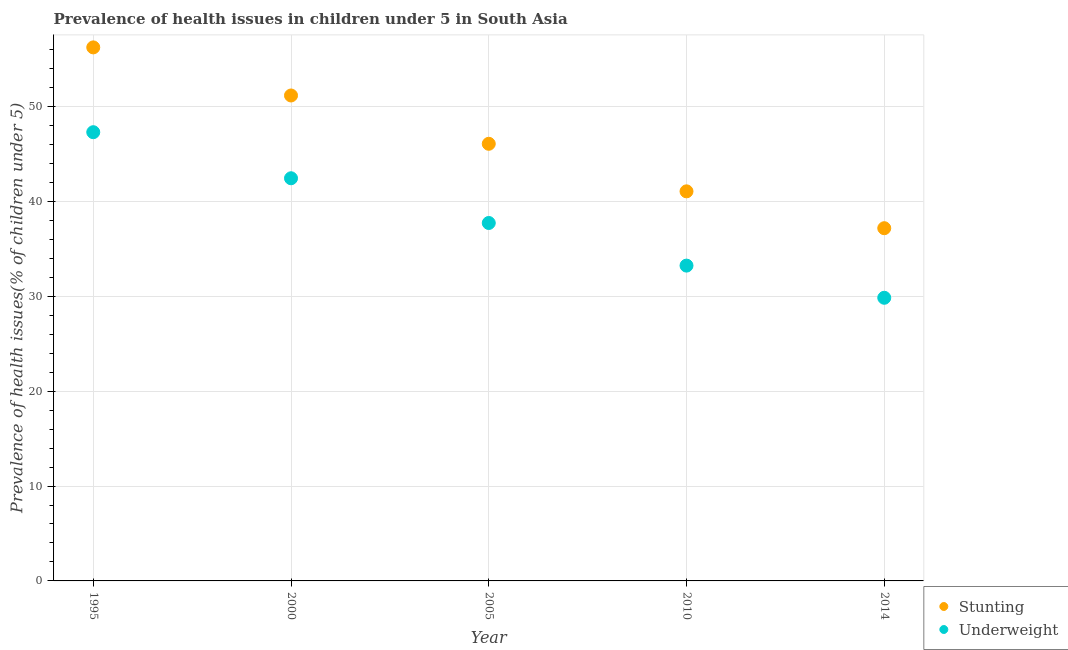What is the percentage of stunted children in 2000?
Give a very brief answer. 51.16. Across all years, what is the maximum percentage of underweight children?
Make the answer very short. 47.29. Across all years, what is the minimum percentage of underweight children?
Offer a terse response. 29.84. In which year was the percentage of stunted children maximum?
Provide a succinct answer. 1995. In which year was the percentage of stunted children minimum?
Offer a very short reply. 2014. What is the total percentage of underweight children in the graph?
Provide a short and direct response. 190.53. What is the difference between the percentage of underweight children in 2000 and that in 2005?
Offer a very short reply. 4.71. What is the difference between the percentage of stunted children in 2000 and the percentage of underweight children in 2005?
Ensure brevity in your answer.  13.44. What is the average percentage of underweight children per year?
Ensure brevity in your answer.  38.11. In the year 2005, what is the difference between the percentage of stunted children and percentage of underweight children?
Keep it short and to the point. 8.35. In how many years, is the percentage of underweight children greater than 38 %?
Make the answer very short. 2. What is the ratio of the percentage of stunted children in 2000 to that in 2010?
Ensure brevity in your answer.  1.25. Is the difference between the percentage of stunted children in 2010 and 2014 greater than the difference between the percentage of underweight children in 2010 and 2014?
Your answer should be very brief. Yes. What is the difference between the highest and the second highest percentage of underweight children?
Make the answer very short. 4.86. What is the difference between the highest and the lowest percentage of underweight children?
Give a very brief answer. 17.45. Is the percentage of stunted children strictly greater than the percentage of underweight children over the years?
Your answer should be very brief. Yes. How many dotlines are there?
Your response must be concise. 2. Are the values on the major ticks of Y-axis written in scientific E-notation?
Ensure brevity in your answer.  No. Does the graph contain any zero values?
Ensure brevity in your answer.  No. How many legend labels are there?
Ensure brevity in your answer.  2. What is the title of the graph?
Ensure brevity in your answer.  Prevalence of health issues in children under 5 in South Asia. Does "Age 65(male)" appear as one of the legend labels in the graph?
Your response must be concise. No. What is the label or title of the Y-axis?
Offer a terse response. Prevalence of health issues(% of children under 5). What is the Prevalence of health issues(% of children under 5) of Stunting in 1995?
Your answer should be compact. 56.23. What is the Prevalence of health issues(% of children under 5) in Underweight in 1995?
Provide a short and direct response. 47.29. What is the Prevalence of health issues(% of children under 5) in Stunting in 2000?
Give a very brief answer. 51.16. What is the Prevalence of health issues(% of children under 5) in Underweight in 2000?
Provide a short and direct response. 42.44. What is the Prevalence of health issues(% of children under 5) in Stunting in 2005?
Offer a very short reply. 46.07. What is the Prevalence of health issues(% of children under 5) in Underweight in 2005?
Provide a short and direct response. 37.72. What is the Prevalence of health issues(% of children under 5) in Stunting in 2010?
Ensure brevity in your answer.  41.06. What is the Prevalence of health issues(% of children under 5) in Underweight in 2010?
Your answer should be very brief. 33.23. What is the Prevalence of health issues(% of children under 5) of Stunting in 2014?
Provide a short and direct response. 37.17. What is the Prevalence of health issues(% of children under 5) in Underweight in 2014?
Your response must be concise. 29.84. Across all years, what is the maximum Prevalence of health issues(% of children under 5) of Stunting?
Offer a very short reply. 56.23. Across all years, what is the maximum Prevalence of health issues(% of children under 5) of Underweight?
Offer a very short reply. 47.29. Across all years, what is the minimum Prevalence of health issues(% of children under 5) of Stunting?
Make the answer very short. 37.17. Across all years, what is the minimum Prevalence of health issues(% of children under 5) of Underweight?
Your answer should be very brief. 29.84. What is the total Prevalence of health issues(% of children under 5) of Stunting in the graph?
Your response must be concise. 231.7. What is the total Prevalence of health issues(% of children under 5) in Underweight in the graph?
Ensure brevity in your answer.  190.53. What is the difference between the Prevalence of health issues(% of children under 5) in Stunting in 1995 and that in 2000?
Provide a succinct answer. 5.07. What is the difference between the Prevalence of health issues(% of children under 5) of Underweight in 1995 and that in 2000?
Your response must be concise. 4.86. What is the difference between the Prevalence of health issues(% of children under 5) in Stunting in 1995 and that in 2005?
Give a very brief answer. 10.16. What is the difference between the Prevalence of health issues(% of children under 5) of Underweight in 1995 and that in 2005?
Provide a succinct answer. 9.57. What is the difference between the Prevalence of health issues(% of children under 5) of Stunting in 1995 and that in 2010?
Give a very brief answer. 15.17. What is the difference between the Prevalence of health issues(% of children under 5) of Underweight in 1995 and that in 2010?
Your answer should be compact. 14.06. What is the difference between the Prevalence of health issues(% of children under 5) in Stunting in 1995 and that in 2014?
Keep it short and to the point. 19.06. What is the difference between the Prevalence of health issues(% of children under 5) of Underweight in 1995 and that in 2014?
Offer a very short reply. 17.45. What is the difference between the Prevalence of health issues(% of children under 5) in Stunting in 2000 and that in 2005?
Offer a very short reply. 5.09. What is the difference between the Prevalence of health issues(% of children under 5) of Underweight in 2000 and that in 2005?
Offer a very short reply. 4.71. What is the difference between the Prevalence of health issues(% of children under 5) of Stunting in 2000 and that in 2010?
Offer a terse response. 10.1. What is the difference between the Prevalence of health issues(% of children under 5) of Underweight in 2000 and that in 2010?
Your answer should be very brief. 9.21. What is the difference between the Prevalence of health issues(% of children under 5) in Stunting in 2000 and that in 2014?
Your answer should be very brief. 13.99. What is the difference between the Prevalence of health issues(% of children under 5) of Underweight in 2000 and that in 2014?
Your response must be concise. 12.6. What is the difference between the Prevalence of health issues(% of children under 5) in Stunting in 2005 and that in 2010?
Give a very brief answer. 5.01. What is the difference between the Prevalence of health issues(% of children under 5) in Underweight in 2005 and that in 2010?
Provide a short and direct response. 4.49. What is the difference between the Prevalence of health issues(% of children under 5) of Stunting in 2005 and that in 2014?
Make the answer very short. 8.9. What is the difference between the Prevalence of health issues(% of children under 5) in Underweight in 2005 and that in 2014?
Ensure brevity in your answer.  7.88. What is the difference between the Prevalence of health issues(% of children under 5) of Stunting in 2010 and that in 2014?
Keep it short and to the point. 3.88. What is the difference between the Prevalence of health issues(% of children under 5) in Underweight in 2010 and that in 2014?
Your answer should be compact. 3.39. What is the difference between the Prevalence of health issues(% of children under 5) in Stunting in 1995 and the Prevalence of health issues(% of children under 5) in Underweight in 2000?
Provide a short and direct response. 13.79. What is the difference between the Prevalence of health issues(% of children under 5) of Stunting in 1995 and the Prevalence of health issues(% of children under 5) of Underweight in 2005?
Provide a short and direct response. 18.51. What is the difference between the Prevalence of health issues(% of children under 5) in Stunting in 1995 and the Prevalence of health issues(% of children under 5) in Underweight in 2010?
Offer a very short reply. 23. What is the difference between the Prevalence of health issues(% of children under 5) of Stunting in 1995 and the Prevalence of health issues(% of children under 5) of Underweight in 2014?
Provide a succinct answer. 26.39. What is the difference between the Prevalence of health issues(% of children under 5) in Stunting in 2000 and the Prevalence of health issues(% of children under 5) in Underweight in 2005?
Your answer should be compact. 13.44. What is the difference between the Prevalence of health issues(% of children under 5) of Stunting in 2000 and the Prevalence of health issues(% of children under 5) of Underweight in 2010?
Offer a terse response. 17.93. What is the difference between the Prevalence of health issues(% of children under 5) in Stunting in 2000 and the Prevalence of health issues(% of children under 5) in Underweight in 2014?
Your answer should be very brief. 21.32. What is the difference between the Prevalence of health issues(% of children under 5) of Stunting in 2005 and the Prevalence of health issues(% of children under 5) of Underweight in 2010?
Your answer should be compact. 12.84. What is the difference between the Prevalence of health issues(% of children under 5) of Stunting in 2005 and the Prevalence of health issues(% of children under 5) of Underweight in 2014?
Make the answer very short. 16.23. What is the difference between the Prevalence of health issues(% of children under 5) of Stunting in 2010 and the Prevalence of health issues(% of children under 5) of Underweight in 2014?
Your answer should be compact. 11.22. What is the average Prevalence of health issues(% of children under 5) of Stunting per year?
Give a very brief answer. 46.34. What is the average Prevalence of health issues(% of children under 5) of Underweight per year?
Make the answer very short. 38.11. In the year 1995, what is the difference between the Prevalence of health issues(% of children under 5) in Stunting and Prevalence of health issues(% of children under 5) in Underweight?
Ensure brevity in your answer.  8.94. In the year 2000, what is the difference between the Prevalence of health issues(% of children under 5) of Stunting and Prevalence of health issues(% of children under 5) of Underweight?
Offer a terse response. 8.72. In the year 2005, what is the difference between the Prevalence of health issues(% of children under 5) in Stunting and Prevalence of health issues(% of children under 5) in Underweight?
Offer a terse response. 8.35. In the year 2010, what is the difference between the Prevalence of health issues(% of children under 5) in Stunting and Prevalence of health issues(% of children under 5) in Underweight?
Your answer should be very brief. 7.83. In the year 2014, what is the difference between the Prevalence of health issues(% of children under 5) of Stunting and Prevalence of health issues(% of children under 5) of Underweight?
Provide a short and direct response. 7.33. What is the ratio of the Prevalence of health issues(% of children under 5) of Stunting in 1995 to that in 2000?
Your answer should be compact. 1.1. What is the ratio of the Prevalence of health issues(% of children under 5) in Underweight in 1995 to that in 2000?
Provide a short and direct response. 1.11. What is the ratio of the Prevalence of health issues(% of children under 5) of Stunting in 1995 to that in 2005?
Keep it short and to the point. 1.22. What is the ratio of the Prevalence of health issues(% of children under 5) in Underweight in 1995 to that in 2005?
Make the answer very short. 1.25. What is the ratio of the Prevalence of health issues(% of children under 5) in Stunting in 1995 to that in 2010?
Your response must be concise. 1.37. What is the ratio of the Prevalence of health issues(% of children under 5) in Underweight in 1995 to that in 2010?
Give a very brief answer. 1.42. What is the ratio of the Prevalence of health issues(% of children under 5) in Stunting in 1995 to that in 2014?
Ensure brevity in your answer.  1.51. What is the ratio of the Prevalence of health issues(% of children under 5) of Underweight in 1995 to that in 2014?
Ensure brevity in your answer.  1.58. What is the ratio of the Prevalence of health issues(% of children under 5) of Stunting in 2000 to that in 2005?
Give a very brief answer. 1.11. What is the ratio of the Prevalence of health issues(% of children under 5) of Underweight in 2000 to that in 2005?
Give a very brief answer. 1.12. What is the ratio of the Prevalence of health issues(% of children under 5) of Stunting in 2000 to that in 2010?
Keep it short and to the point. 1.25. What is the ratio of the Prevalence of health issues(% of children under 5) in Underweight in 2000 to that in 2010?
Your response must be concise. 1.28. What is the ratio of the Prevalence of health issues(% of children under 5) in Stunting in 2000 to that in 2014?
Your response must be concise. 1.38. What is the ratio of the Prevalence of health issues(% of children under 5) of Underweight in 2000 to that in 2014?
Your answer should be compact. 1.42. What is the ratio of the Prevalence of health issues(% of children under 5) of Stunting in 2005 to that in 2010?
Your response must be concise. 1.12. What is the ratio of the Prevalence of health issues(% of children under 5) of Underweight in 2005 to that in 2010?
Offer a terse response. 1.14. What is the ratio of the Prevalence of health issues(% of children under 5) in Stunting in 2005 to that in 2014?
Ensure brevity in your answer.  1.24. What is the ratio of the Prevalence of health issues(% of children under 5) in Underweight in 2005 to that in 2014?
Keep it short and to the point. 1.26. What is the ratio of the Prevalence of health issues(% of children under 5) in Stunting in 2010 to that in 2014?
Your response must be concise. 1.1. What is the ratio of the Prevalence of health issues(% of children under 5) of Underweight in 2010 to that in 2014?
Provide a succinct answer. 1.11. What is the difference between the highest and the second highest Prevalence of health issues(% of children under 5) of Stunting?
Offer a terse response. 5.07. What is the difference between the highest and the second highest Prevalence of health issues(% of children under 5) in Underweight?
Keep it short and to the point. 4.86. What is the difference between the highest and the lowest Prevalence of health issues(% of children under 5) of Stunting?
Make the answer very short. 19.06. What is the difference between the highest and the lowest Prevalence of health issues(% of children under 5) in Underweight?
Offer a terse response. 17.45. 